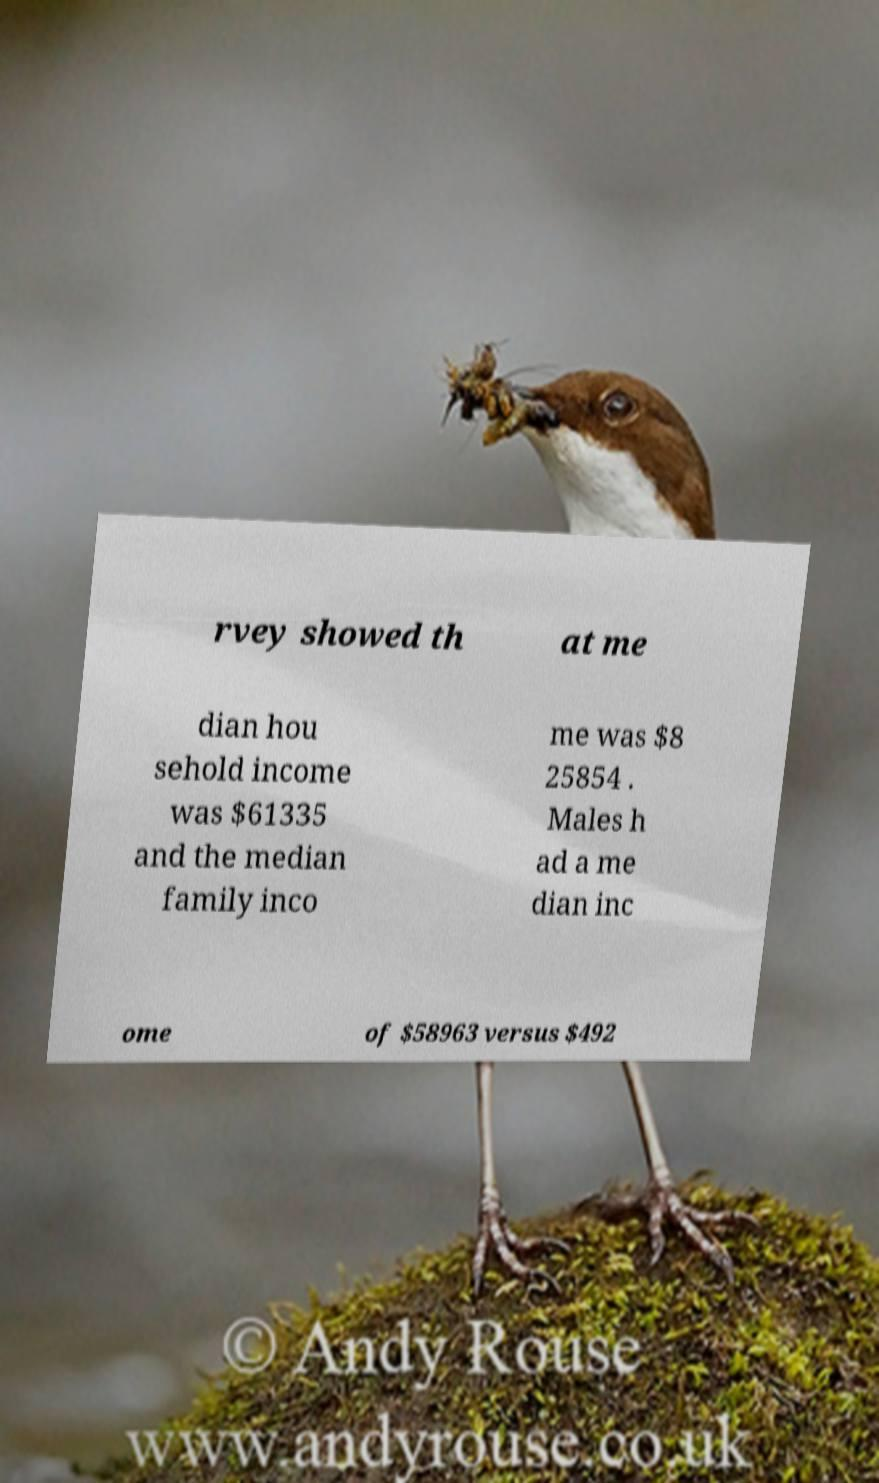For documentation purposes, I need the text within this image transcribed. Could you provide that? rvey showed th at me dian hou sehold income was $61335 and the median family inco me was $8 25854 . Males h ad a me dian inc ome of $58963 versus $492 